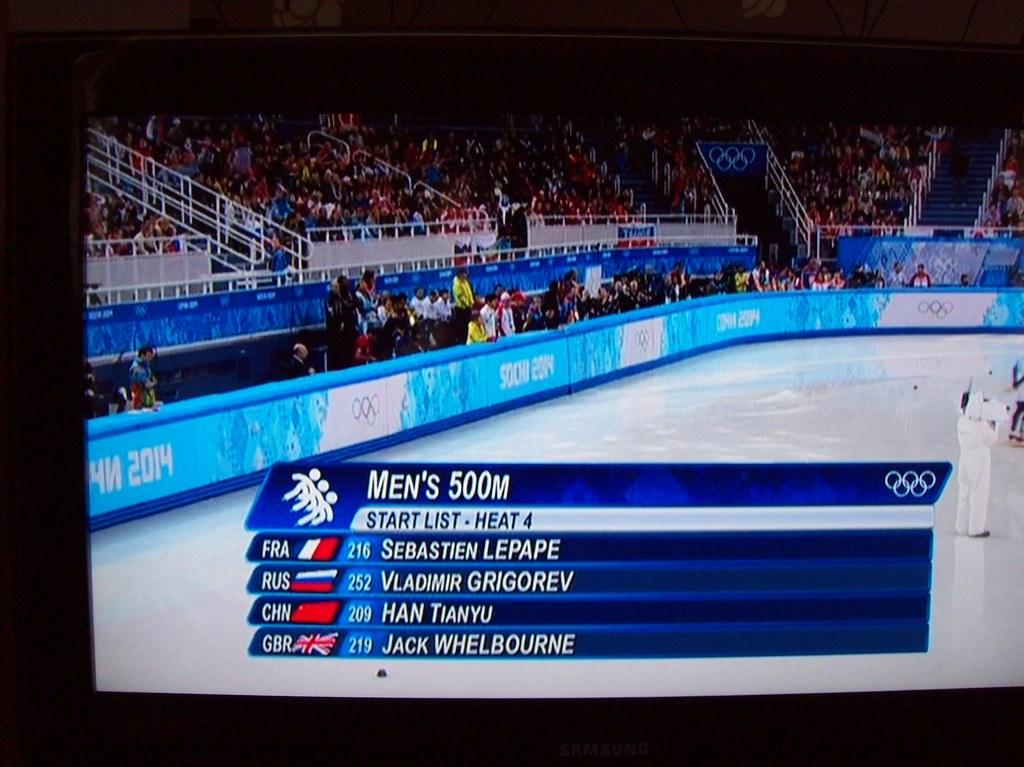<image>
Render a clear and concise summary of the photo. Some statistics for the Men's 500 meter race are shown on a TV screen. 